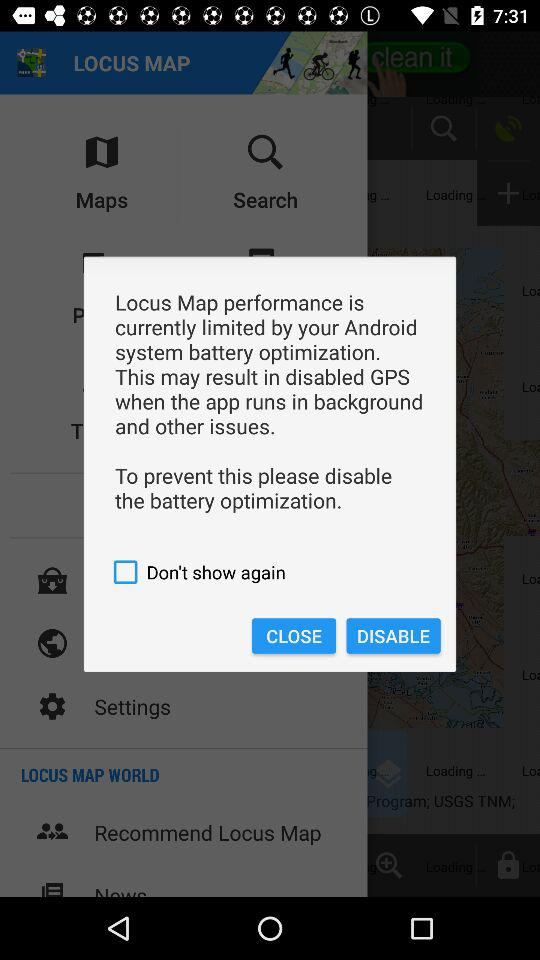What is the status of "Don't show again"? The status is "off". 